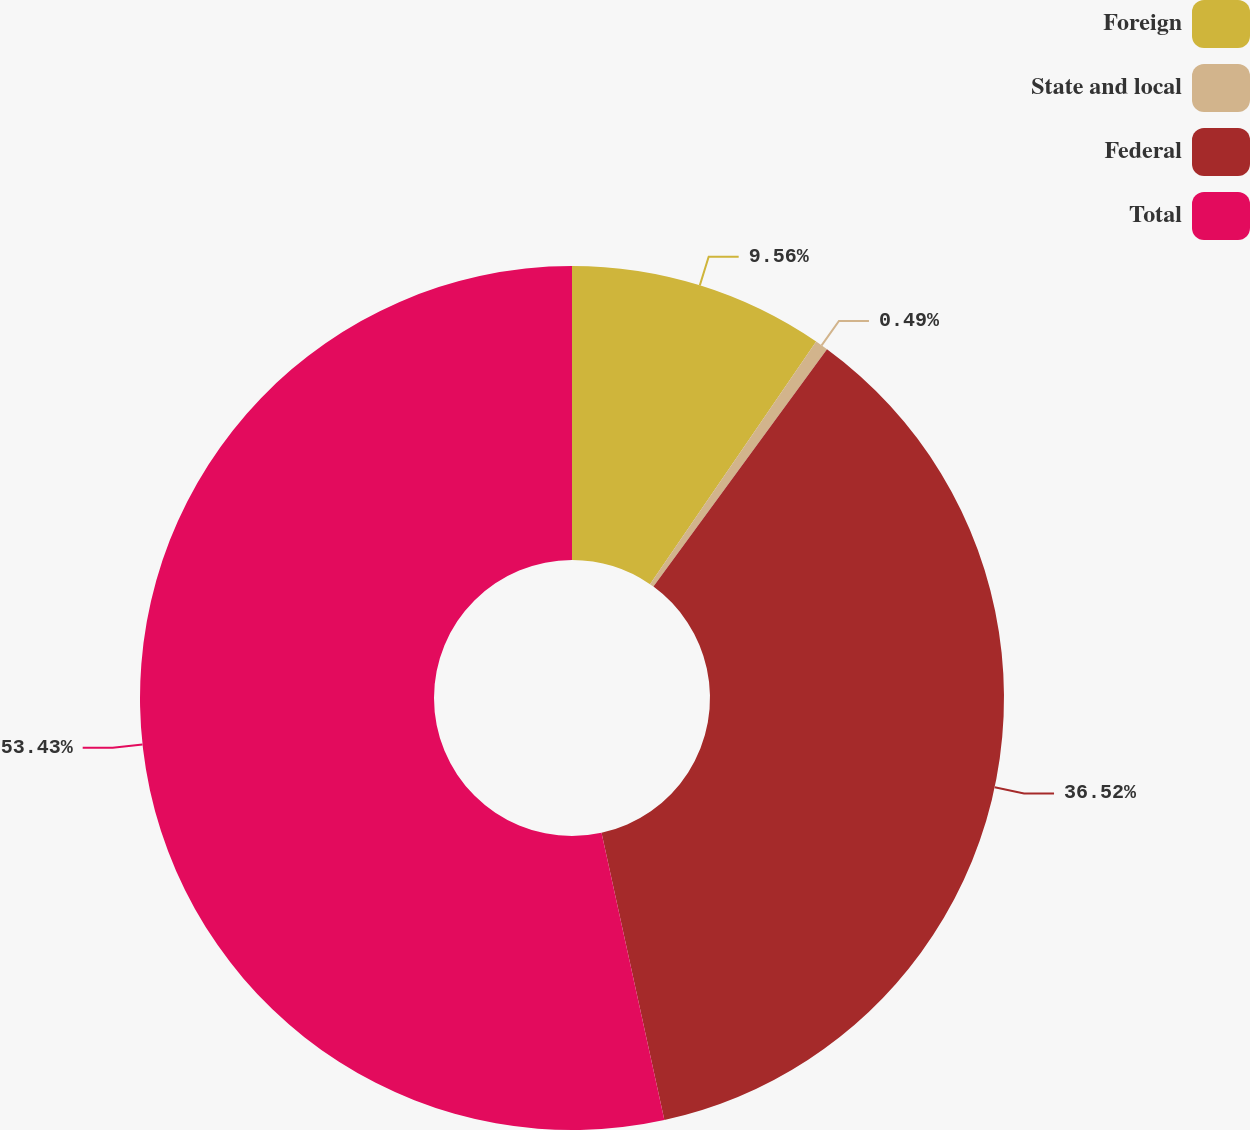Convert chart. <chart><loc_0><loc_0><loc_500><loc_500><pie_chart><fcel>Foreign<fcel>State and local<fcel>Federal<fcel>Total<nl><fcel>9.56%<fcel>0.49%<fcel>36.52%<fcel>53.43%<nl></chart> 